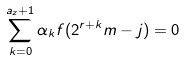Convert formula to latex. <formula><loc_0><loc_0><loc_500><loc_500>\sum _ { k = 0 } ^ { a _ { z } + 1 } \alpha _ { k } f ( 2 ^ { r + k } m - j ) = 0</formula> 